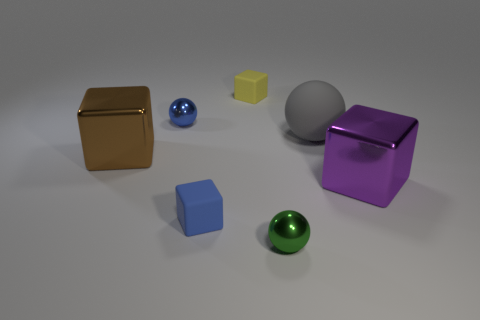Is there a gray thing made of the same material as the green object?
Provide a succinct answer. No. What is the object that is both behind the large brown metal block and on the left side of the blue rubber block made of?
Your answer should be compact. Metal. What color is the big rubber thing?
Offer a terse response. Gray. What number of other large purple metal objects have the same shape as the big purple object?
Provide a succinct answer. 0. Is the material of the purple block that is to the right of the yellow block the same as the tiny blue object that is behind the large matte sphere?
Give a very brief answer. Yes. What is the size of the metal cube that is to the left of the object that is in front of the blue rubber block?
Make the answer very short. Large. Is there anything else that is the same size as the blue matte thing?
Offer a very short reply. Yes. There is a big gray object that is the same shape as the green thing; what material is it?
Ensure brevity in your answer.  Rubber. Do the rubber object that is to the left of the yellow block and the blue object that is behind the big matte ball have the same shape?
Ensure brevity in your answer.  No. Is the number of tiny blue blocks greater than the number of cyan shiny things?
Provide a succinct answer. Yes. 